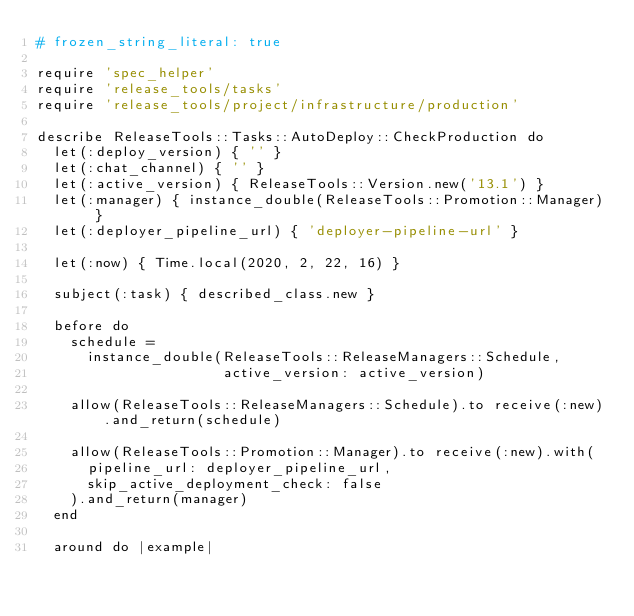<code> <loc_0><loc_0><loc_500><loc_500><_Ruby_># frozen_string_literal: true

require 'spec_helper'
require 'release_tools/tasks'
require 'release_tools/project/infrastructure/production'

describe ReleaseTools::Tasks::AutoDeploy::CheckProduction do
  let(:deploy_version) { '' }
  let(:chat_channel) { '' }
  let(:active_version) { ReleaseTools::Version.new('13.1') }
  let(:manager) { instance_double(ReleaseTools::Promotion::Manager) }
  let(:deployer_pipeline_url) { 'deployer-pipeline-url' }

  let(:now) { Time.local(2020, 2, 22, 16) }

  subject(:task) { described_class.new }

  before do
    schedule =
      instance_double(ReleaseTools::ReleaseManagers::Schedule,
                      active_version: active_version)

    allow(ReleaseTools::ReleaseManagers::Schedule).to receive(:new).and_return(schedule)

    allow(ReleaseTools::Promotion::Manager).to receive(:new).with(
      pipeline_url: deployer_pipeline_url,
      skip_active_deployment_check: false
    ).and_return(manager)
  end

  around do |example|</code> 